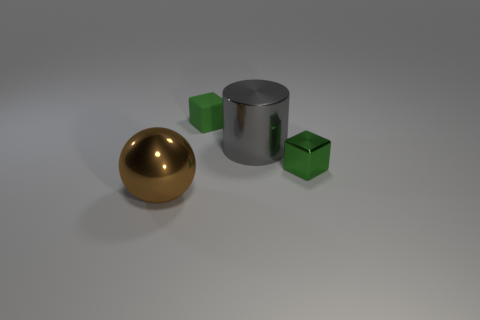Add 4 big gray objects. How many objects exist? 8 Subtract all large cyan metallic cylinders. Subtract all large objects. How many objects are left? 2 Add 2 big gray objects. How many big gray objects are left? 3 Add 4 gray metallic blocks. How many gray metallic blocks exist? 4 Subtract 1 green cubes. How many objects are left? 3 